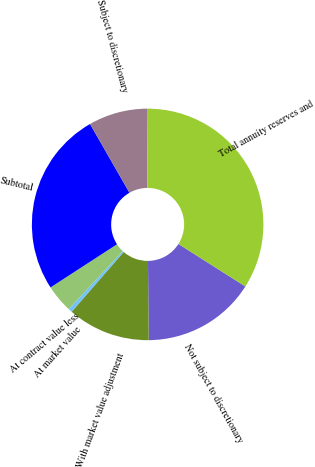Convert chart to OTSL. <chart><loc_0><loc_0><loc_500><loc_500><pie_chart><fcel>Not subject to discretionary<fcel>With market value adjustment<fcel>At market value<fcel>At contract value less<fcel>Subtotal<fcel>Subject to discretionary<fcel>Total annuity reserves and<nl><fcel>15.85%<fcel>11.55%<fcel>0.54%<fcel>3.9%<fcel>25.87%<fcel>8.2%<fcel>34.08%<nl></chart> 